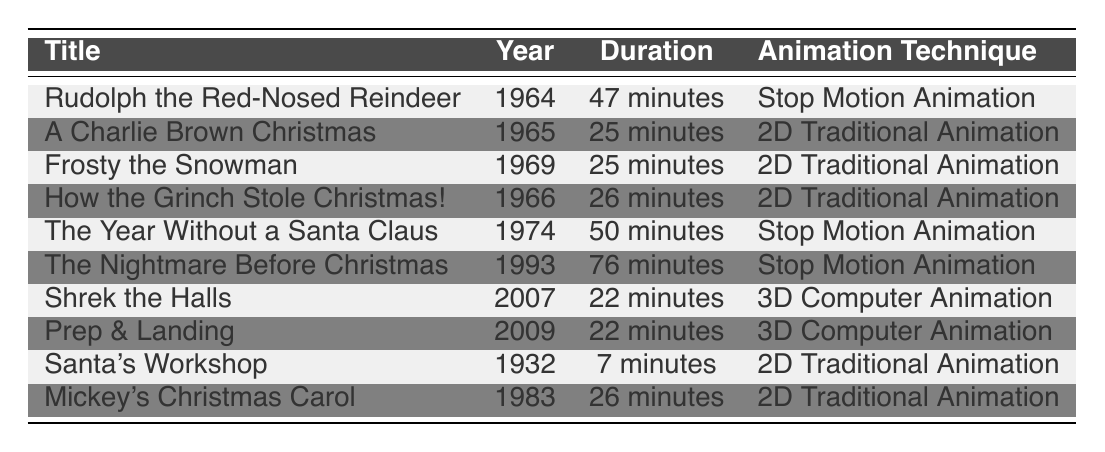What is the duration of "The Nightmare Before Christmas"? The table lists "The Nightmare Before Christmas" under the Title column and shows its corresponding Duration is "76 minutes".
Answer: 76 minutes Which animation technique was used in "A Charlie Brown Christmas"? Looking at the table, "A Charlie Brown Christmas" is associated with the animation technique listed as "2D Traditional Animation".
Answer: 2D Traditional Animation How many holiday specials were produced in the 1960s? By examining the Year column, the entries for the 1960s include "Rudolph the Red-Nosed Reindeer" (1964), "A Charlie Brown Christmas" (1965), "How the Grinch Stole Christmas!" (1966), and "Frosty the Snowman" (1969), totaling four specials.
Answer: 4 Is "Shrek the Halls" longer in duration than "Santa's Workshop"? Comparing the Duration values, "Shrek the Halls" has a duration of "22 minutes" while "Santa's Workshop" has "7 minutes". Since 22 is greater than 7, the statement is true.
Answer: Yes What is the average duration of the specials listed from the 1970s and later? The durations from the 1970s and later are 50 minutes ("The Year Without a Santa Claus"), 76 minutes ("The Nightmare Before Christmas"), 22 minutes ("Shrek the Halls"), 22 minutes ("Prep & Landing"). The total duration is 50 + 76 + 22 + 22 = 170 minutes. There are 4 specials, so the average duration is 170 divided by 4, which equals 42.5 minutes.
Answer: 42.5 minutes How many of the listed holiday specials used stop motion animation? The entries using stop motion animation are "Rudolph the Red-Nosed Reindeer", "The Year Without a Santa Claus", and "The Nightmare Before Christmas", totaling three specials.
Answer: 3 What is the difference in duration between "The Year Without a Santa Claus" and "Frosty the Snowman"? "The Year Without a Santa Claus" runs for 50 minutes, while "Frosty the Snowman" has a duration of 25 minutes. The difference is calculated as 50 minutes minus 25 minutes, which equals 25 minutes.
Answer: 25 minutes Is there a holiday special from 2000 or later that uses 2D Traditional Animation? By checking the table, both "Shrek the Halls" and "Prep & Landing" from 2000 or later utilize 3D Computer Animation, and there are no holiday specials from that timeframe using 2D Traditional Animation.
Answer: No 